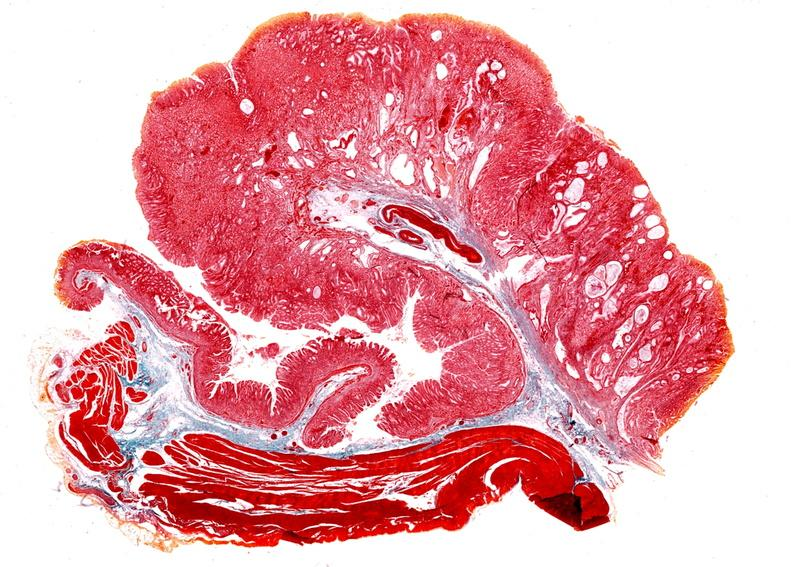what is present?
Answer the question using a single word or phrase. Gastrointestinal 